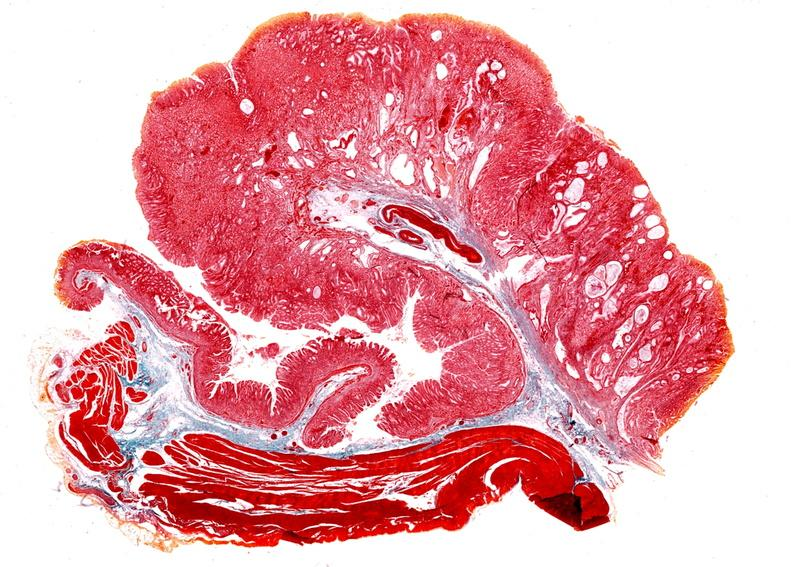what is present?
Answer the question using a single word or phrase. Gastrointestinal 